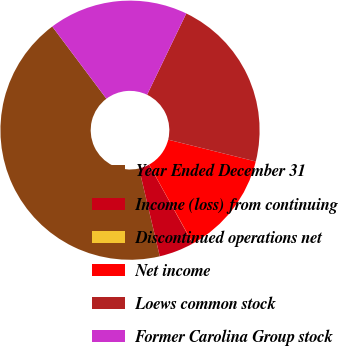<chart> <loc_0><loc_0><loc_500><loc_500><pie_chart><fcel>Year Ended December 31<fcel>Income (loss) from continuing<fcel>Discontinued operations net<fcel>Net income<fcel>Loews common stock<fcel>Former Carolina Group stock<nl><fcel>43.45%<fcel>4.36%<fcel>0.02%<fcel>13.05%<fcel>21.73%<fcel>17.39%<nl></chart> 